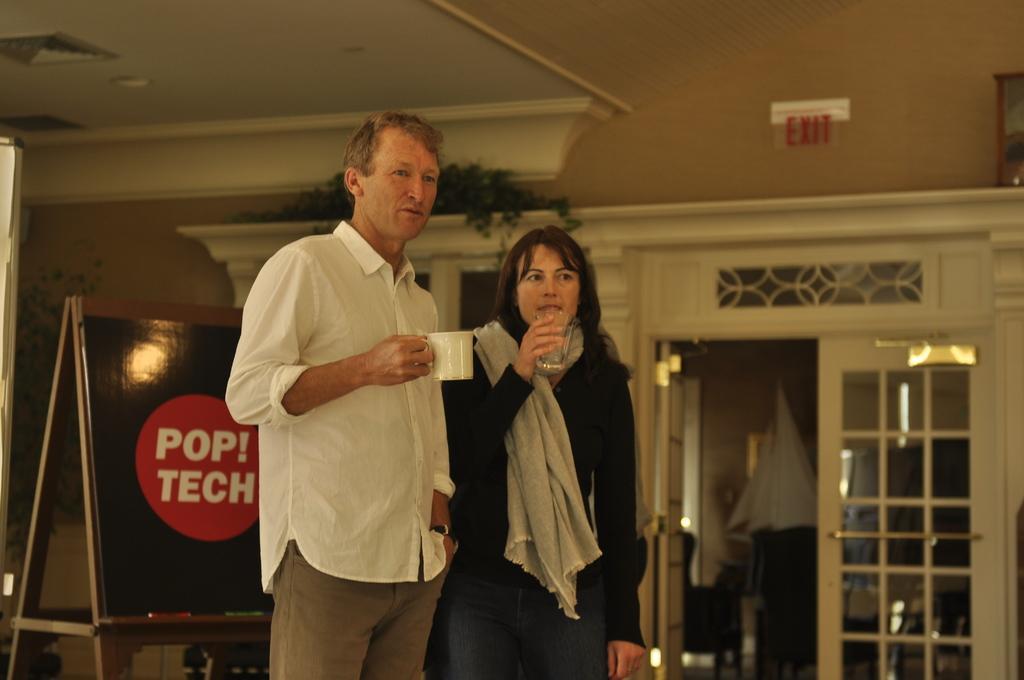In one or two sentences, can you explain what this image depicts? In this image I can see two persons are standing on the floor and holding cups in their hand. In the background I can see a wall, houseplants, board and a door. This image is taken may be in a hall. 